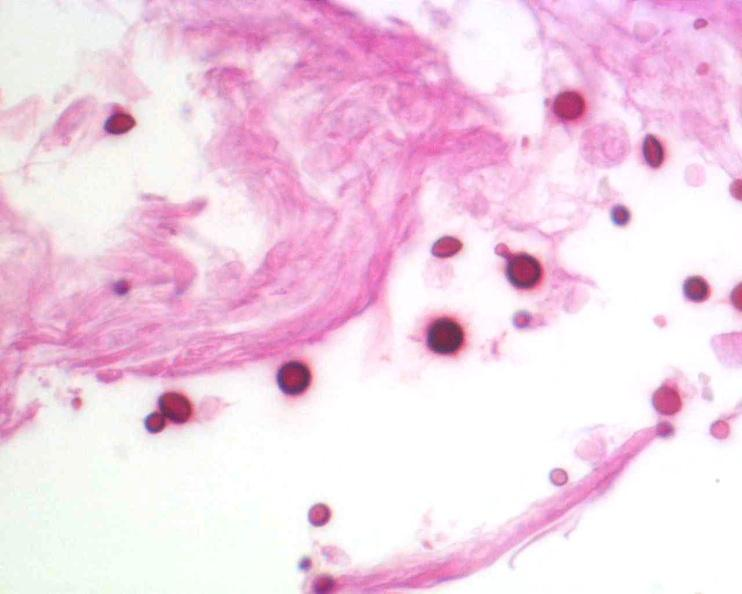where is this?
Answer the question using a single word or phrase. Nervous 